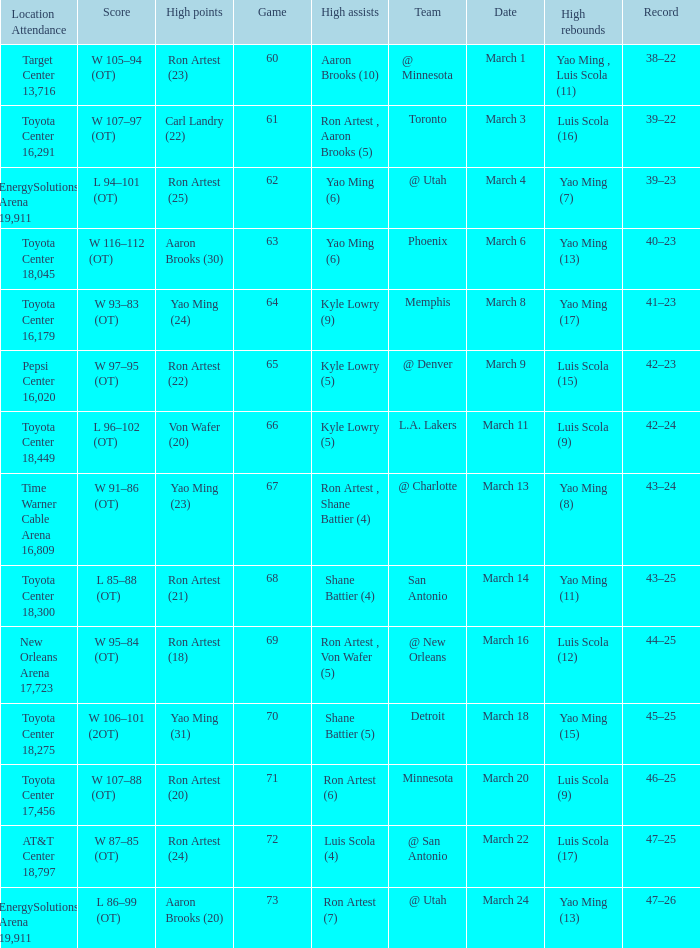On what date did the Rockets play Memphis? March 8. 